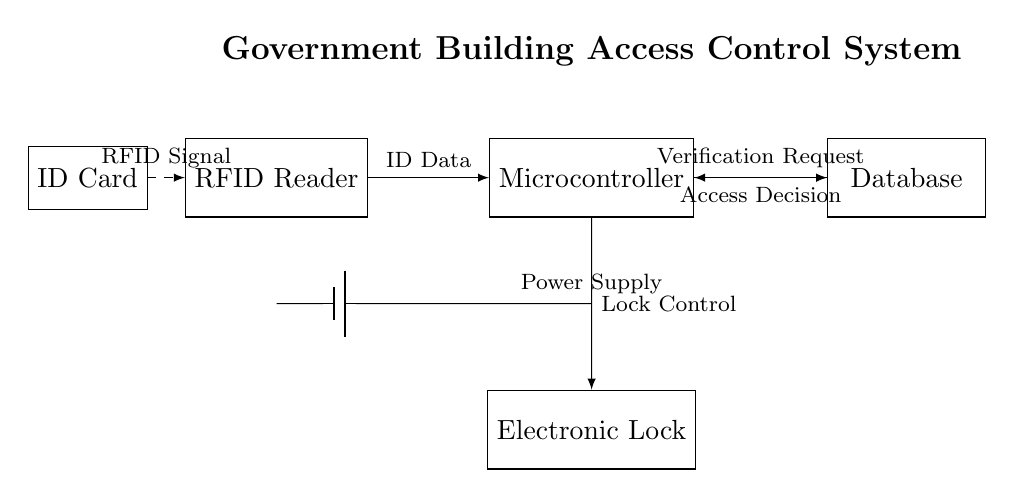What is the main component used for reading IDs? The main component for reading IDs is the RFID Reader, which is designed to detect and read RFID signals from ID cards in close proximity.
Answer: RFID Reader What type of database is used in this system? The circuit diagram indicates that a Database component is included to store user information and validate access requests based on the ID data received from the RFID Reader.
Answer: Database What controls the electronic lock? The electronic lock is controlled by signals sent from the Microcontroller, which processes the ID data, verifies it with the database, and then sends a command to lock or unlock based on the access decision.
Answer: Microcontroller Which component provides the power supply for the circuit? The power supply in this circuit is represented by a battery, which powers all the components within the system, ensuring they operate correctly.
Answer: Battery How does the RFID Reader interact with the ID Card? The RFID Reader receives an RFID signal when the ID Card is present within its range, establishing a communication link to read the ID information encoded in the card.
Answer: RFID Signal What is the purpose of the connections between the components? The connections defined in the circuit diagram allow for data flow and communication between the RFID Reader, Microcontroller, Database, and Electronic Lock, enabling the system to function as a cohesive unit for access control.
Answer: Communication 